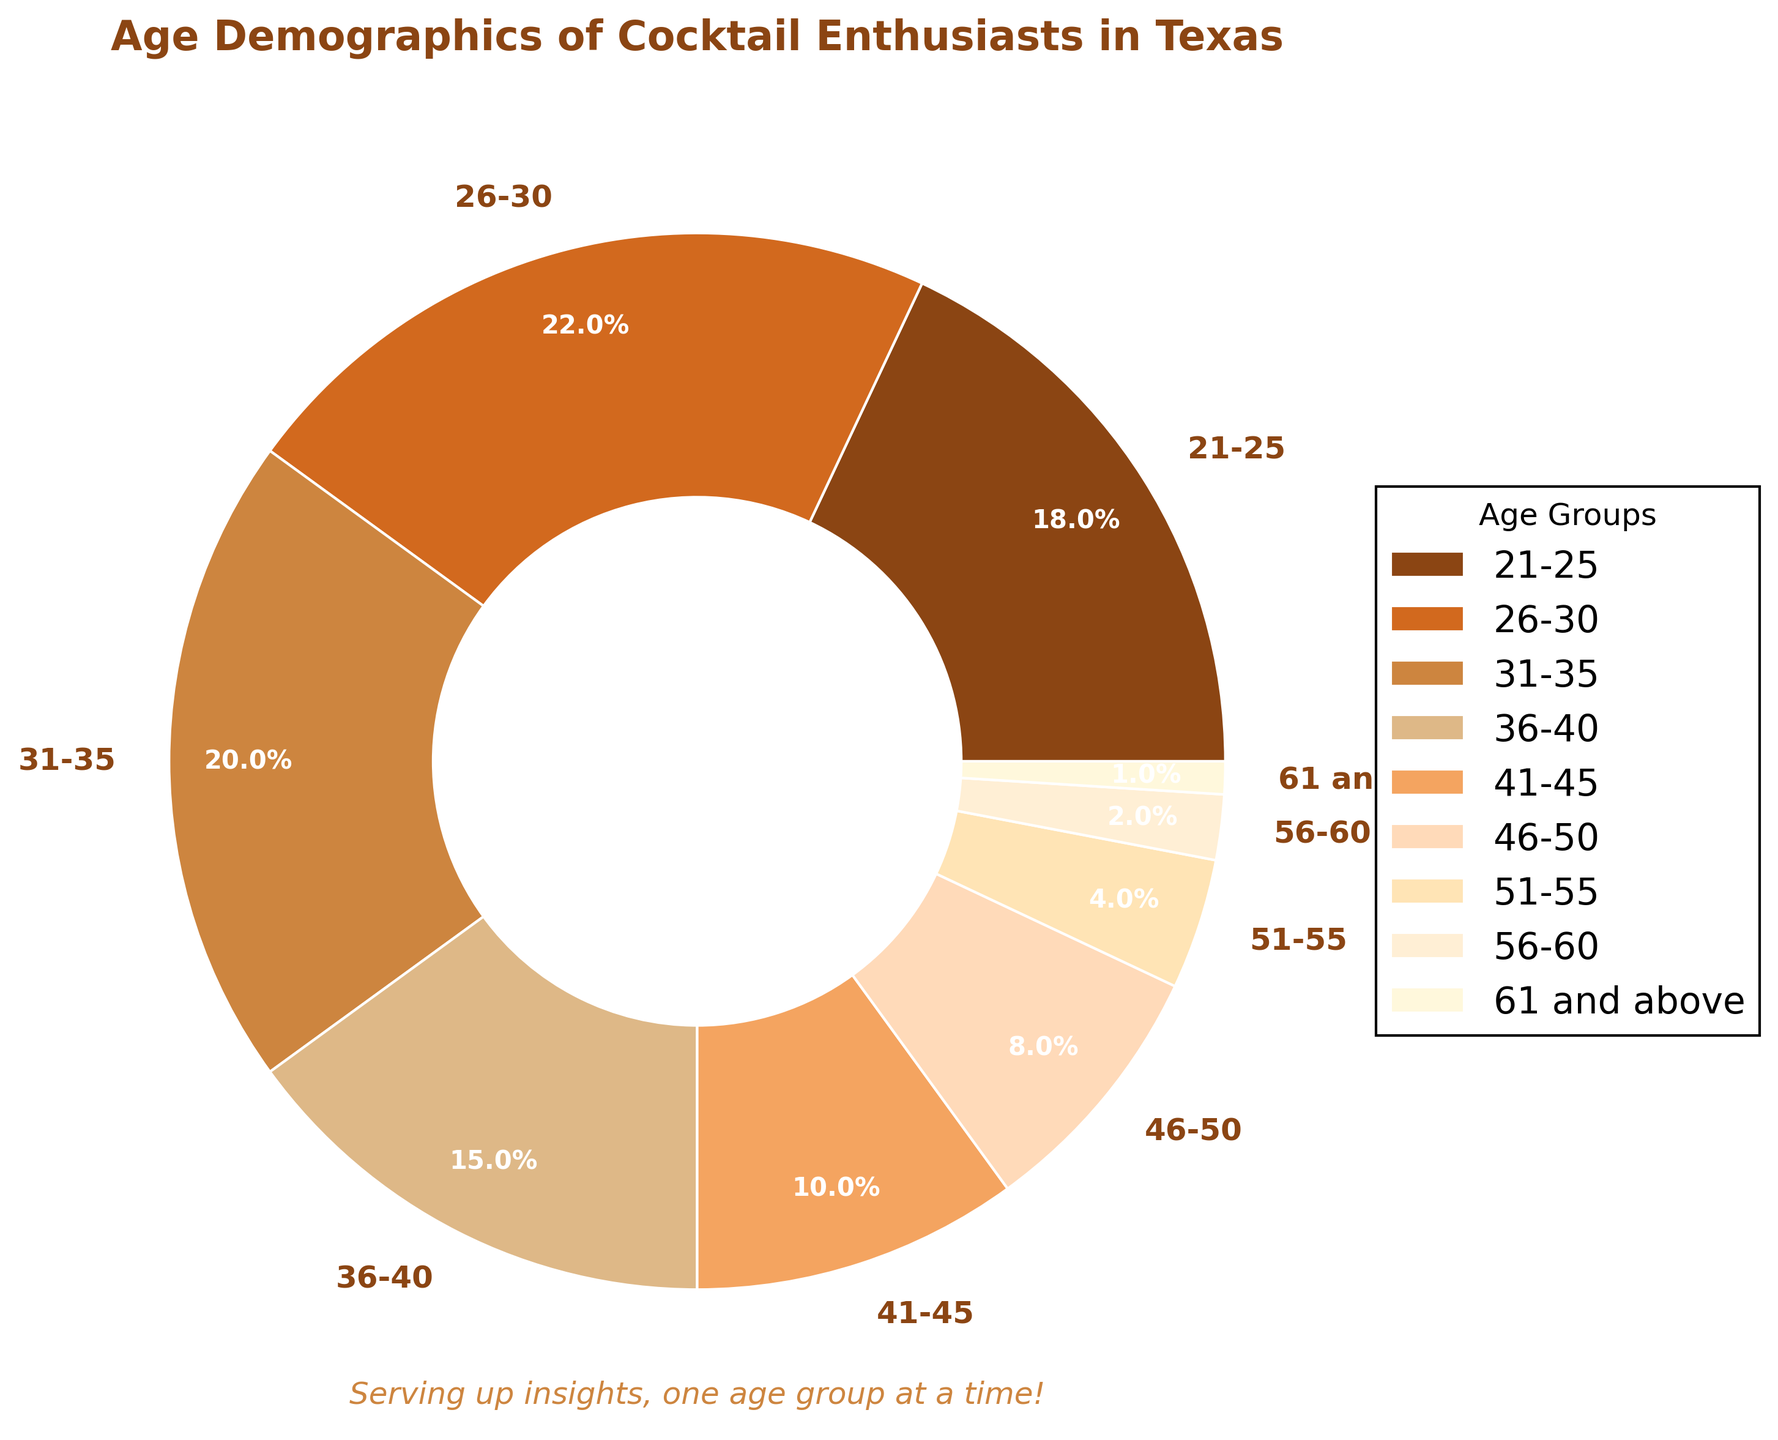What's the largest age group of cocktail enthusiasts? The largest age group is represented by the section with the biggest slice of the pie chart, which is labeled "26-30" with a percentage of 22%.
Answer: 26-30 Which age group has the smallest representation? The smallest representation is the thinnest slice in the chart, which is labeled "61 and above," accounting for 1%.
Answer: 61 and above How many age groups have percentages less than 10%? By looking at the chart, the groups "46-50" (8%), "51-55" (4%), "56-60" (2%), and "61 and above" (1%) all have percentages less than 10%. Count them: 4 groups.
Answer: 4 Comparing the "21-25" and "41-45" groups, which one is larger and by how much? The "21-25" group is 18%, and the "41-45" group is 10%. The difference is 18% - 10% = 8%. The "21-25" group is larger by 8%.
Answer: 21-25 by 8% What is the combined percentage for enthusiasts aged 51 and above? Add the percentages for "51-55" (4%), "56-60" (2%), and "61 and above" (1%): 4% + 2% + 1% = 7%.
Answer: 7% Which age groups together make up more than half of the pie chart? The largest contributing groups are "26-30" (22%) and "31-35" (20%). Adding these gives 22% + 20% = 42%. Next, adding the "21-25" group gives 42% + 18% = 60%, which is more than half. Therefore, the groups "21-25," "26-30," and "31-35" together exceed 50%.
Answer: 21-25, 26-30, 31-35 Is the percentage of enthusiasts in the "36-40" age group more than double that in the "46-50" group? "36-40" has 15%, and "46-50" has 8%. Twice 8% is 16%, so 15% is slightly less than double 8%.
Answer: No Which colors represent the top three age groups? The top three slices are "26-30" (22%), "31-35" (20%), and "21-25" (18%). The corresponding colors in the pie chart are second, third, and first from the custom palette used. Answer by naming the colors directly visible. The answer should be in the appearance order.
Answer: Copper for 26-30, Light Brown for 31-35, Dark Brown for 21-25 